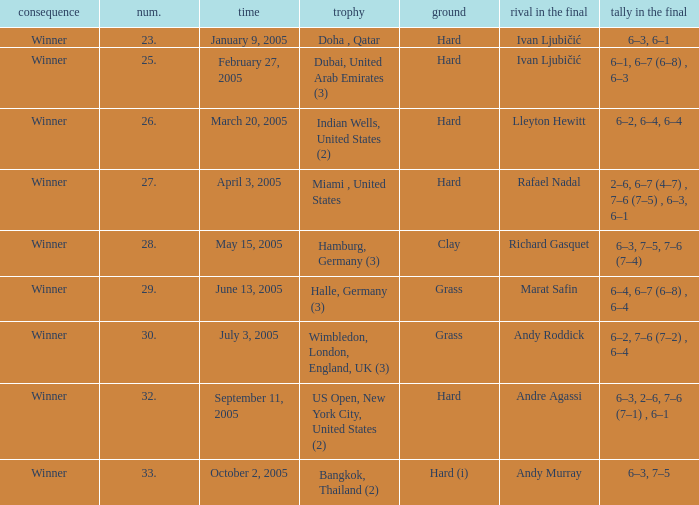Parse the table in full. {'header': ['consequence', 'num.', 'time', 'trophy', 'ground', 'rival in the final', 'tally in the final'], 'rows': [['Winner', '23.', 'January 9, 2005', 'Doha , Qatar', 'Hard', 'Ivan Ljubičić', '6–3, 6–1'], ['Winner', '25.', 'February 27, 2005', 'Dubai, United Arab Emirates (3)', 'Hard', 'Ivan Ljubičić', '6–1, 6–7 (6–8) , 6–3'], ['Winner', '26.', 'March 20, 2005', 'Indian Wells, United States (2)', 'Hard', 'Lleyton Hewitt', '6–2, 6–4, 6–4'], ['Winner', '27.', 'April 3, 2005', 'Miami , United States', 'Hard', 'Rafael Nadal', '2–6, 6–7 (4–7) , 7–6 (7–5) , 6–3, 6–1'], ['Winner', '28.', 'May 15, 2005', 'Hamburg, Germany (3)', 'Clay', 'Richard Gasquet', '6–3, 7–5, 7–6 (7–4)'], ['Winner', '29.', 'June 13, 2005', 'Halle, Germany (3)', 'Grass', 'Marat Safin', '6–4, 6–7 (6–8) , 6–4'], ['Winner', '30.', 'July 3, 2005', 'Wimbledon, London, England, UK (3)', 'Grass', 'Andy Roddick', '6–2, 7–6 (7–2) , 6–4'], ['Winner', '32.', 'September 11, 2005', 'US Open, New York City, United States (2)', 'Hard', 'Andre Agassi', '6–3, 2–6, 7–6 (7–1) , 6–1'], ['Winner', '33.', 'October 2, 2005', 'Bangkok, Thailand (2)', 'Hard (i)', 'Andy Murray', '6–3, 7–5']]} Marat Safin is the opponent in the final in what championship? Halle, Germany (3). 